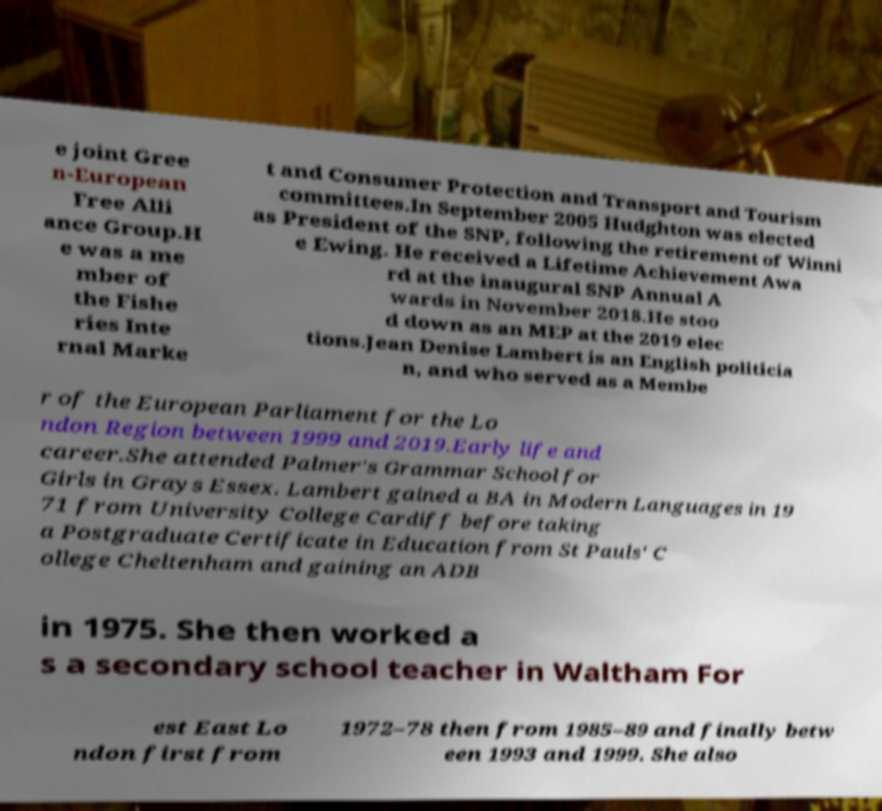I need the written content from this picture converted into text. Can you do that? e joint Gree n-European Free Alli ance Group.H e was a me mber of the Fishe ries Inte rnal Marke t and Consumer Protection and Transport and Tourism committees.In September 2005 Hudghton was elected as President of the SNP, following the retirement of Winni e Ewing. He received a Lifetime Achievement Awa rd at the inaugural SNP Annual A wards in November 2018.He stoo d down as an MEP at the 2019 elec tions.Jean Denise Lambert is an English politicia n, and who served as a Membe r of the European Parliament for the Lo ndon Region between 1999 and 2019.Early life and career.She attended Palmer's Grammar School for Girls in Grays Essex. Lambert gained a BA in Modern Languages in 19 71 from University College Cardiff before taking a Postgraduate Certificate in Education from St Pauls' C ollege Cheltenham and gaining an ADB in 1975. She then worked a s a secondary school teacher in Waltham For est East Lo ndon first from 1972–78 then from 1985–89 and finally betw een 1993 and 1999. She also 